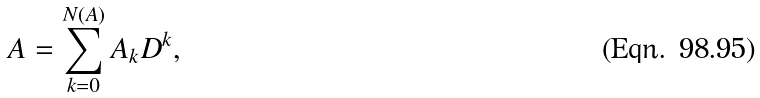<formula> <loc_0><loc_0><loc_500><loc_500>A = \sum _ { k = 0 } ^ { N ( A ) } A _ { k } D ^ { k } ,</formula> 